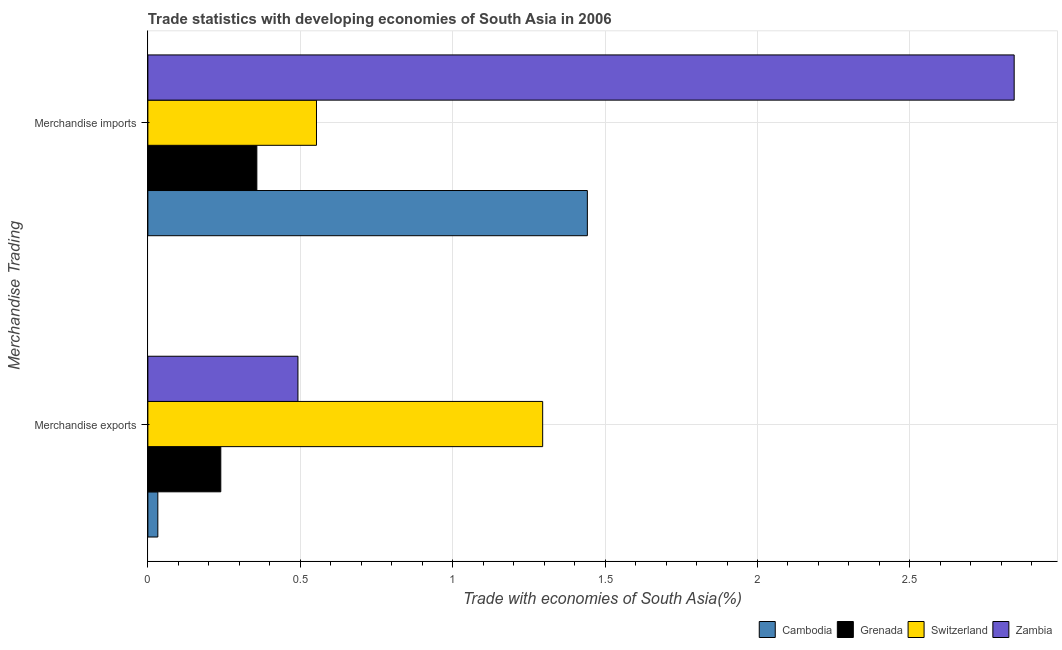How many bars are there on the 2nd tick from the bottom?
Keep it short and to the point. 4. What is the merchandise imports in Grenada?
Your response must be concise. 0.36. Across all countries, what is the maximum merchandise imports?
Your response must be concise. 2.84. Across all countries, what is the minimum merchandise exports?
Give a very brief answer. 0.03. In which country was the merchandise exports maximum?
Your response must be concise. Switzerland. In which country was the merchandise imports minimum?
Ensure brevity in your answer.  Grenada. What is the total merchandise exports in the graph?
Your response must be concise. 2.06. What is the difference between the merchandise exports in Grenada and that in Switzerland?
Your response must be concise. -1.06. What is the difference between the merchandise exports in Zambia and the merchandise imports in Grenada?
Your answer should be very brief. 0.13. What is the average merchandise exports per country?
Your answer should be compact. 0.51. What is the difference between the merchandise exports and merchandise imports in Zambia?
Your answer should be compact. -2.35. What is the ratio of the merchandise imports in Grenada to that in Switzerland?
Provide a short and direct response. 0.65. Is the merchandise imports in Zambia less than that in Grenada?
Ensure brevity in your answer.  No. What does the 3rd bar from the top in Merchandise imports represents?
Your response must be concise. Grenada. What does the 4th bar from the bottom in Merchandise exports represents?
Your answer should be compact. Zambia. How many bars are there?
Keep it short and to the point. 8. Are all the bars in the graph horizontal?
Ensure brevity in your answer.  Yes. What is the difference between two consecutive major ticks on the X-axis?
Your answer should be compact. 0.5. Are the values on the major ticks of X-axis written in scientific E-notation?
Make the answer very short. No. Does the graph contain grids?
Your answer should be compact. Yes. Where does the legend appear in the graph?
Offer a terse response. Bottom right. How many legend labels are there?
Ensure brevity in your answer.  4. How are the legend labels stacked?
Make the answer very short. Horizontal. What is the title of the graph?
Your answer should be very brief. Trade statistics with developing economies of South Asia in 2006. What is the label or title of the X-axis?
Give a very brief answer. Trade with economies of South Asia(%). What is the label or title of the Y-axis?
Keep it short and to the point. Merchandise Trading. What is the Trade with economies of South Asia(%) in Cambodia in Merchandise exports?
Ensure brevity in your answer.  0.03. What is the Trade with economies of South Asia(%) in Grenada in Merchandise exports?
Provide a succinct answer. 0.24. What is the Trade with economies of South Asia(%) of Switzerland in Merchandise exports?
Make the answer very short. 1.3. What is the Trade with economies of South Asia(%) of Zambia in Merchandise exports?
Keep it short and to the point. 0.49. What is the Trade with economies of South Asia(%) of Cambodia in Merchandise imports?
Ensure brevity in your answer.  1.44. What is the Trade with economies of South Asia(%) in Grenada in Merchandise imports?
Your answer should be very brief. 0.36. What is the Trade with economies of South Asia(%) of Switzerland in Merchandise imports?
Offer a terse response. 0.55. What is the Trade with economies of South Asia(%) of Zambia in Merchandise imports?
Ensure brevity in your answer.  2.84. Across all Merchandise Trading, what is the maximum Trade with economies of South Asia(%) of Cambodia?
Keep it short and to the point. 1.44. Across all Merchandise Trading, what is the maximum Trade with economies of South Asia(%) of Grenada?
Your answer should be compact. 0.36. Across all Merchandise Trading, what is the maximum Trade with economies of South Asia(%) in Switzerland?
Your answer should be compact. 1.3. Across all Merchandise Trading, what is the maximum Trade with economies of South Asia(%) in Zambia?
Give a very brief answer. 2.84. Across all Merchandise Trading, what is the minimum Trade with economies of South Asia(%) in Cambodia?
Provide a short and direct response. 0.03. Across all Merchandise Trading, what is the minimum Trade with economies of South Asia(%) of Grenada?
Ensure brevity in your answer.  0.24. Across all Merchandise Trading, what is the minimum Trade with economies of South Asia(%) in Switzerland?
Give a very brief answer. 0.55. Across all Merchandise Trading, what is the minimum Trade with economies of South Asia(%) of Zambia?
Offer a terse response. 0.49. What is the total Trade with economies of South Asia(%) of Cambodia in the graph?
Keep it short and to the point. 1.47. What is the total Trade with economies of South Asia(%) in Grenada in the graph?
Give a very brief answer. 0.6. What is the total Trade with economies of South Asia(%) of Switzerland in the graph?
Keep it short and to the point. 1.85. What is the total Trade with economies of South Asia(%) in Zambia in the graph?
Offer a very short reply. 3.33. What is the difference between the Trade with economies of South Asia(%) of Cambodia in Merchandise exports and that in Merchandise imports?
Keep it short and to the point. -1.41. What is the difference between the Trade with economies of South Asia(%) in Grenada in Merchandise exports and that in Merchandise imports?
Give a very brief answer. -0.12. What is the difference between the Trade with economies of South Asia(%) of Switzerland in Merchandise exports and that in Merchandise imports?
Ensure brevity in your answer.  0.74. What is the difference between the Trade with economies of South Asia(%) of Zambia in Merchandise exports and that in Merchandise imports?
Make the answer very short. -2.35. What is the difference between the Trade with economies of South Asia(%) in Cambodia in Merchandise exports and the Trade with economies of South Asia(%) in Grenada in Merchandise imports?
Provide a succinct answer. -0.32. What is the difference between the Trade with economies of South Asia(%) of Cambodia in Merchandise exports and the Trade with economies of South Asia(%) of Switzerland in Merchandise imports?
Offer a terse response. -0.52. What is the difference between the Trade with economies of South Asia(%) of Cambodia in Merchandise exports and the Trade with economies of South Asia(%) of Zambia in Merchandise imports?
Give a very brief answer. -2.81. What is the difference between the Trade with economies of South Asia(%) in Grenada in Merchandise exports and the Trade with economies of South Asia(%) in Switzerland in Merchandise imports?
Give a very brief answer. -0.31. What is the difference between the Trade with economies of South Asia(%) in Grenada in Merchandise exports and the Trade with economies of South Asia(%) in Zambia in Merchandise imports?
Make the answer very short. -2.6. What is the difference between the Trade with economies of South Asia(%) of Switzerland in Merchandise exports and the Trade with economies of South Asia(%) of Zambia in Merchandise imports?
Keep it short and to the point. -1.55. What is the average Trade with economies of South Asia(%) of Cambodia per Merchandise Trading?
Provide a succinct answer. 0.74. What is the average Trade with economies of South Asia(%) in Grenada per Merchandise Trading?
Offer a very short reply. 0.3. What is the average Trade with economies of South Asia(%) in Switzerland per Merchandise Trading?
Ensure brevity in your answer.  0.92. What is the average Trade with economies of South Asia(%) of Zambia per Merchandise Trading?
Ensure brevity in your answer.  1.67. What is the difference between the Trade with economies of South Asia(%) in Cambodia and Trade with economies of South Asia(%) in Grenada in Merchandise exports?
Keep it short and to the point. -0.21. What is the difference between the Trade with economies of South Asia(%) of Cambodia and Trade with economies of South Asia(%) of Switzerland in Merchandise exports?
Ensure brevity in your answer.  -1.26. What is the difference between the Trade with economies of South Asia(%) in Cambodia and Trade with economies of South Asia(%) in Zambia in Merchandise exports?
Provide a succinct answer. -0.46. What is the difference between the Trade with economies of South Asia(%) of Grenada and Trade with economies of South Asia(%) of Switzerland in Merchandise exports?
Ensure brevity in your answer.  -1.06. What is the difference between the Trade with economies of South Asia(%) in Grenada and Trade with economies of South Asia(%) in Zambia in Merchandise exports?
Provide a short and direct response. -0.25. What is the difference between the Trade with economies of South Asia(%) in Switzerland and Trade with economies of South Asia(%) in Zambia in Merchandise exports?
Offer a terse response. 0.8. What is the difference between the Trade with economies of South Asia(%) in Cambodia and Trade with economies of South Asia(%) in Grenada in Merchandise imports?
Keep it short and to the point. 1.08. What is the difference between the Trade with economies of South Asia(%) of Cambodia and Trade with economies of South Asia(%) of Switzerland in Merchandise imports?
Your response must be concise. 0.89. What is the difference between the Trade with economies of South Asia(%) of Cambodia and Trade with economies of South Asia(%) of Zambia in Merchandise imports?
Offer a terse response. -1.4. What is the difference between the Trade with economies of South Asia(%) of Grenada and Trade with economies of South Asia(%) of Switzerland in Merchandise imports?
Provide a succinct answer. -0.2. What is the difference between the Trade with economies of South Asia(%) in Grenada and Trade with economies of South Asia(%) in Zambia in Merchandise imports?
Offer a very short reply. -2.48. What is the difference between the Trade with economies of South Asia(%) of Switzerland and Trade with economies of South Asia(%) of Zambia in Merchandise imports?
Provide a short and direct response. -2.29. What is the ratio of the Trade with economies of South Asia(%) in Cambodia in Merchandise exports to that in Merchandise imports?
Your answer should be compact. 0.02. What is the ratio of the Trade with economies of South Asia(%) of Grenada in Merchandise exports to that in Merchandise imports?
Your response must be concise. 0.67. What is the ratio of the Trade with economies of South Asia(%) in Switzerland in Merchandise exports to that in Merchandise imports?
Keep it short and to the point. 2.34. What is the ratio of the Trade with economies of South Asia(%) in Zambia in Merchandise exports to that in Merchandise imports?
Give a very brief answer. 0.17. What is the difference between the highest and the second highest Trade with economies of South Asia(%) in Cambodia?
Provide a succinct answer. 1.41. What is the difference between the highest and the second highest Trade with economies of South Asia(%) in Grenada?
Offer a terse response. 0.12. What is the difference between the highest and the second highest Trade with economies of South Asia(%) of Switzerland?
Give a very brief answer. 0.74. What is the difference between the highest and the second highest Trade with economies of South Asia(%) of Zambia?
Provide a succinct answer. 2.35. What is the difference between the highest and the lowest Trade with economies of South Asia(%) of Cambodia?
Keep it short and to the point. 1.41. What is the difference between the highest and the lowest Trade with economies of South Asia(%) in Grenada?
Your answer should be very brief. 0.12. What is the difference between the highest and the lowest Trade with economies of South Asia(%) in Switzerland?
Give a very brief answer. 0.74. What is the difference between the highest and the lowest Trade with economies of South Asia(%) in Zambia?
Keep it short and to the point. 2.35. 